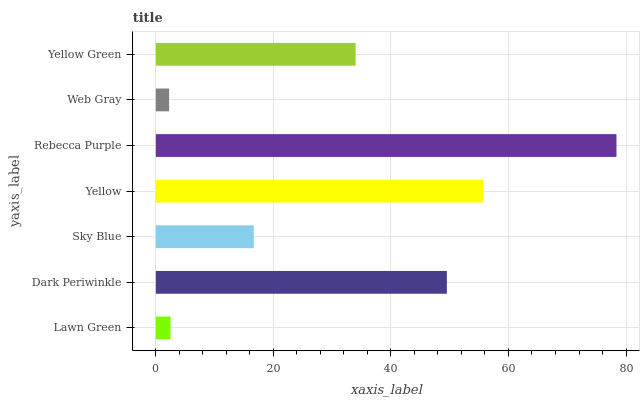Is Web Gray the minimum?
Answer yes or no. Yes. Is Rebecca Purple the maximum?
Answer yes or no. Yes. Is Dark Periwinkle the minimum?
Answer yes or no. No. Is Dark Periwinkle the maximum?
Answer yes or no. No. Is Dark Periwinkle greater than Lawn Green?
Answer yes or no. Yes. Is Lawn Green less than Dark Periwinkle?
Answer yes or no. Yes. Is Lawn Green greater than Dark Periwinkle?
Answer yes or no. No. Is Dark Periwinkle less than Lawn Green?
Answer yes or no. No. Is Yellow Green the high median?
Answer yes or no. Yes. Is Yellow Green the low median?
Answer yes or no. Yes. Is Yellow the high median?
Answer yes or no. No. Is Rebecca Purple the low median?
Answer yes or no. No. 